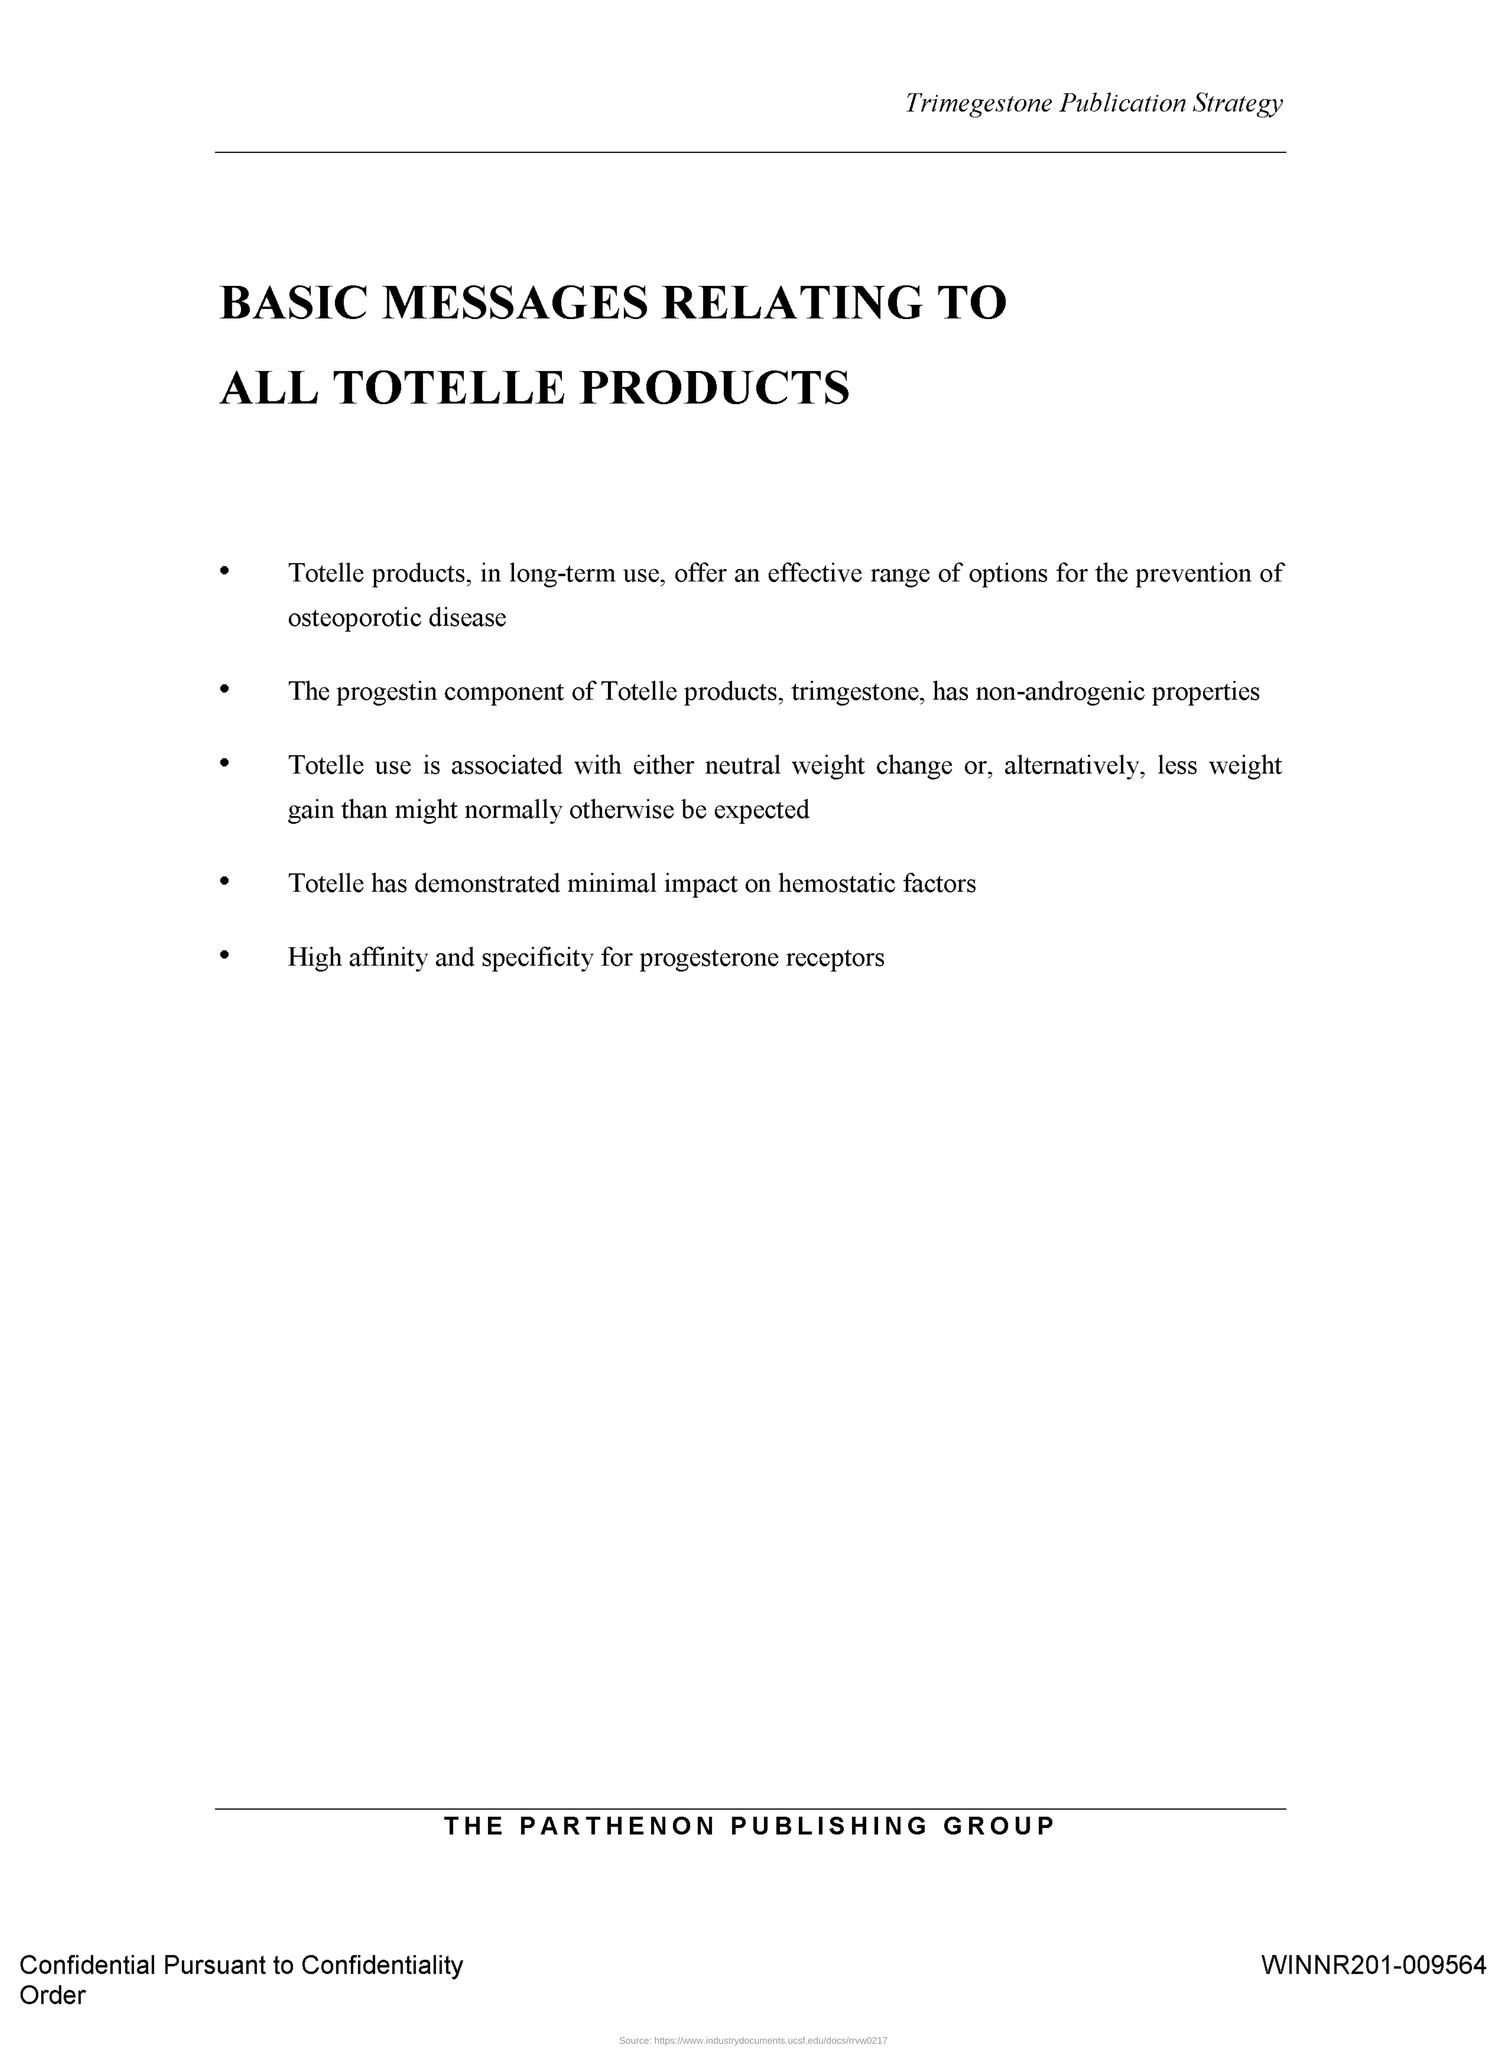Mention a couple of crucial points in this snapshot. The document number is WINNR201-009564. 